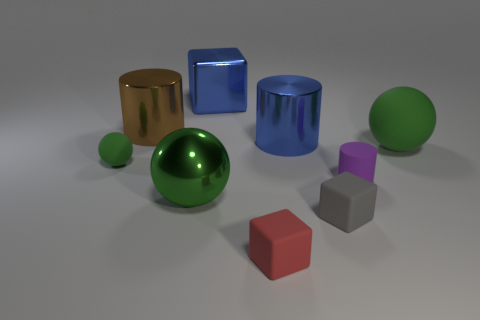There is a metal thing that is the same color as the shiny block; what size is it?
Your response must be concise. Large. Are there any other things that have the same color as the big rubber thing?
Provide a succinct answer. Yes. There is a rubber sphere that is behind the rubber sphere that is left of the brown thing; is there a purple matte cylinder that is right of it?
Your answer should be very brief. No. There is a big sphere in front of the large rubber object; does it have the same color as the rubber sphere that is to the right of the big brown cylinder?
Keep it short and to the point. Yes. There is a blue thing that is the same size as the blue block; what is it made of?
Provide a succinct answer. Metal. There is a green matte thing that is left of the tiny cube that is right of the big metal cylinder that is on the right side of the green metal ball; how big is it?
Provide a short and direct response. Small. What number of other things are the same material as the brown object?
Make the answer very short. 3. There is a green matte thing that is to the left of the blue metal block; how big is it?
Give a very brief answer. Small. What number of objects are in front of the small green thing and right of the small gray thing?
Your answer should be compact. 1. What material is the big green object that is behind the ball left of the brown metal cylinder?
Make the answer very short. Rubber. 